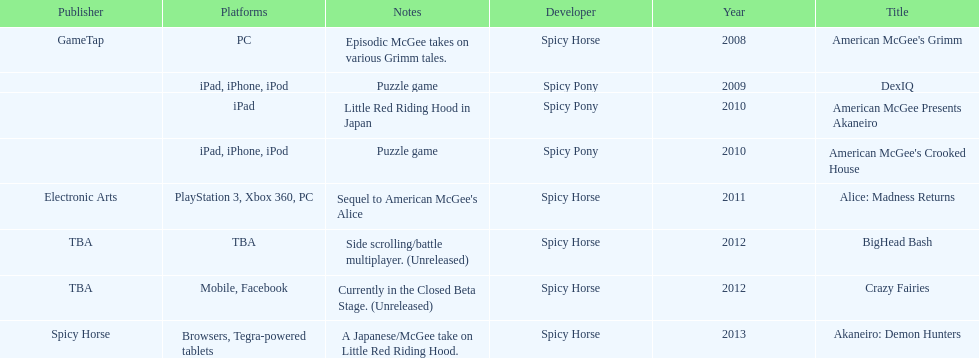What is the first title on this chart? American McGee's Grimm. 